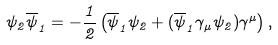Convert formula to latex. <formula><loc_0><loc_0><loc_500><loc_500>\psi _ { 2 } \overline { \psi } _ { 1 } = - \frac { 1 } { 2 } \left ( \overline { \psi } _ { 1 } \psi _ { 2 } + ( \overline { \psi } _ { 1 } \gamma _ { \mu } \psi _ { 2 } ) \gamma ^ { \mu } \right ) ,</formula> 